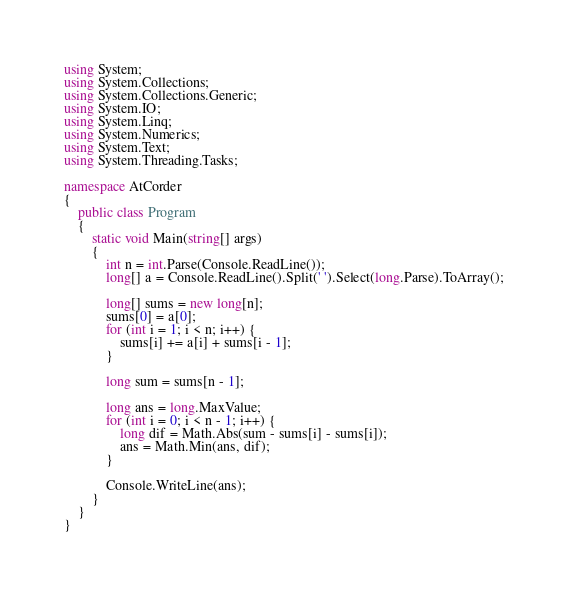Convert code to text. <code><loc_0><loc_0><loc_500><loc_500><_C#_>using System;
using System.Collections;
using System.Collections.Generic;
using System.IO;
using System.Linq;
using System.Numerics;
using System.Text;
using System.Threading.Tasks;

namespace AtCorder
{
	public class Program
	{
		static void Main(string[] args)
		{
			int n = int.Parse(Console.ReadLine());
			long[] a = Console.ReadLine().Split(' ').Select(long.Parse).ToArray();

			long[] sums = new long[n];
			sums[0] = a[0];
			for (int i = 1; i < n; i++) {
				sums[i] += a[i] + sums[i - 1];
			}

			long sum = sums[n - 1];

			long ans = long.MaxValue;
			for (int i = 0; i < n - 1; i++) {
				long dif = Math.Abs(sum - sums[i] - sums[i]);
				ans = Math.Min(ans, dif);
			}

			Console.WriteLine(ans);
		}
	}
}</code> 